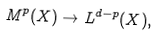<formula> <loc_0><loc_0><loc_500><loc_500>M ^ { p } ( X ) \rightarrow L ^ { d - p } ( X ) ,</formula> 